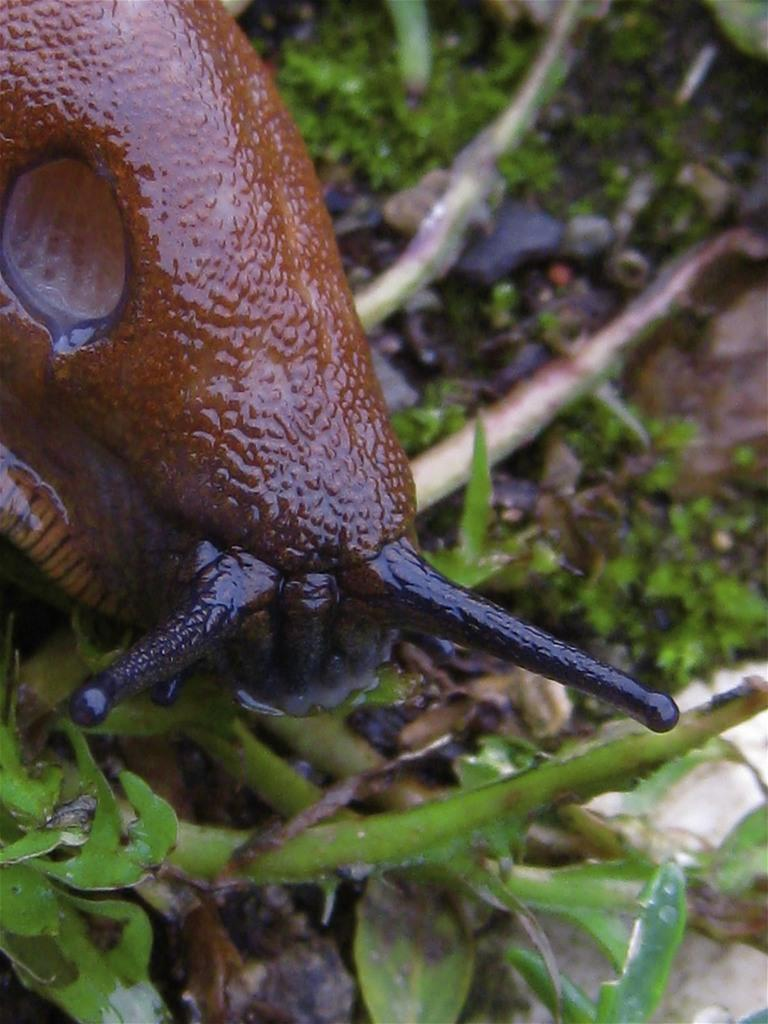What is: What type of animal is on the ground in the image? There is a snail on the ground in the image. What else can be seen in the image besides the snail? There are plants in the image. What type of parcel is being delivered by the snail in the image? There is no parcel present in the image, and the snail is not delivering anything. How does the steam affect the snail's movement in the image? There is no steam present in the image, so it does not affect the snail's movement. 